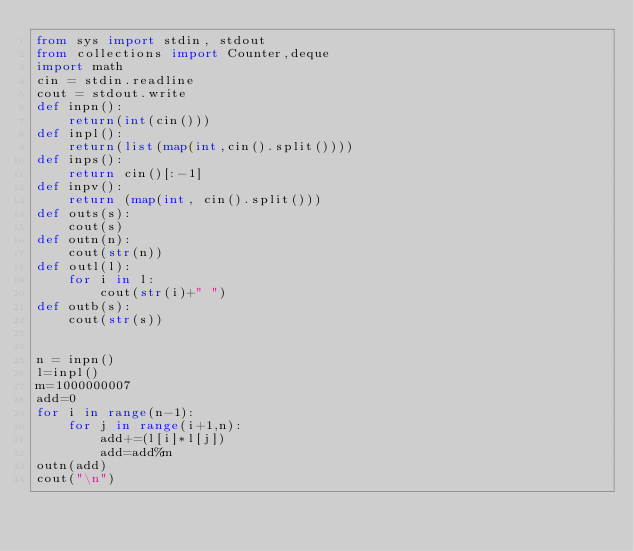<code> <loc_0><loc_0><loc_500><loc_500><_Python_>from sys import stdin, stdout
from collections import Counter,deque
import math
cin = stdin.readline
cout = stdout.write
def inpn():
    return(int(cin()))
def inpl():
    return(list(map(int,cin().split())))
def inps():
    return cin()[:-1]
def inpv():
    return (map(int, cin().split()))
def outs(s):
    cout(s)
def outn(n):
    cout(str(n))
def outl(l):
    for i in l:
        cout(str(i)+" ")
def outb(s):
    cout(str(s))


n = inpn()
l=inpl()
m=1000000007
add=0
for i in range(n-1):
    for j in range(i+1,n):
        add+=(l[i]*l[j])
        add=add%m
outn(add)
cout("\n")
















</code> 